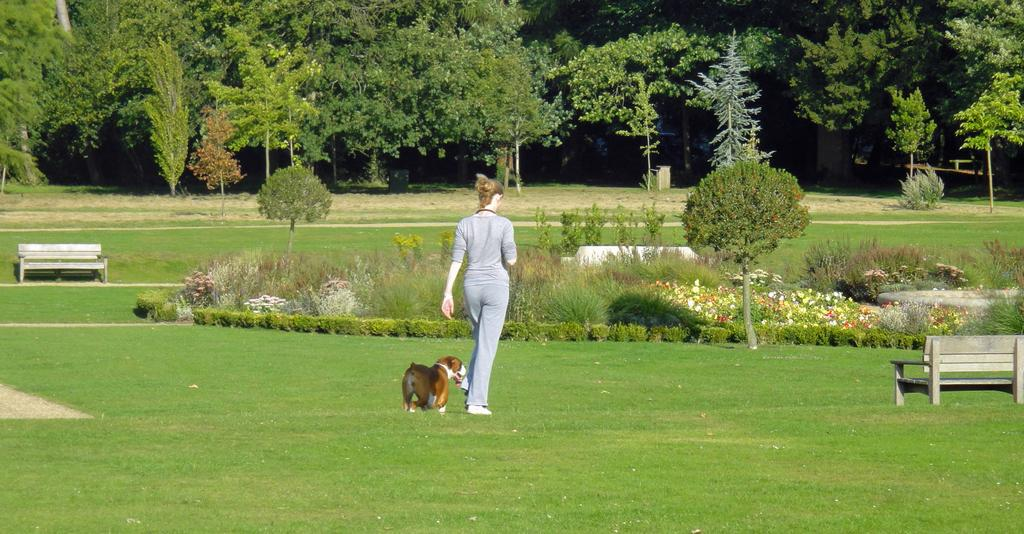Who or what is present in the image? There is a person and a dog in the image. What can be seen on the ground in the image? There are benches on the ground in the image. What is visible in the background of the image? Trees are present in the background of the image. What type of eggnog is being served in the image? There is no eggnog present in the image. 